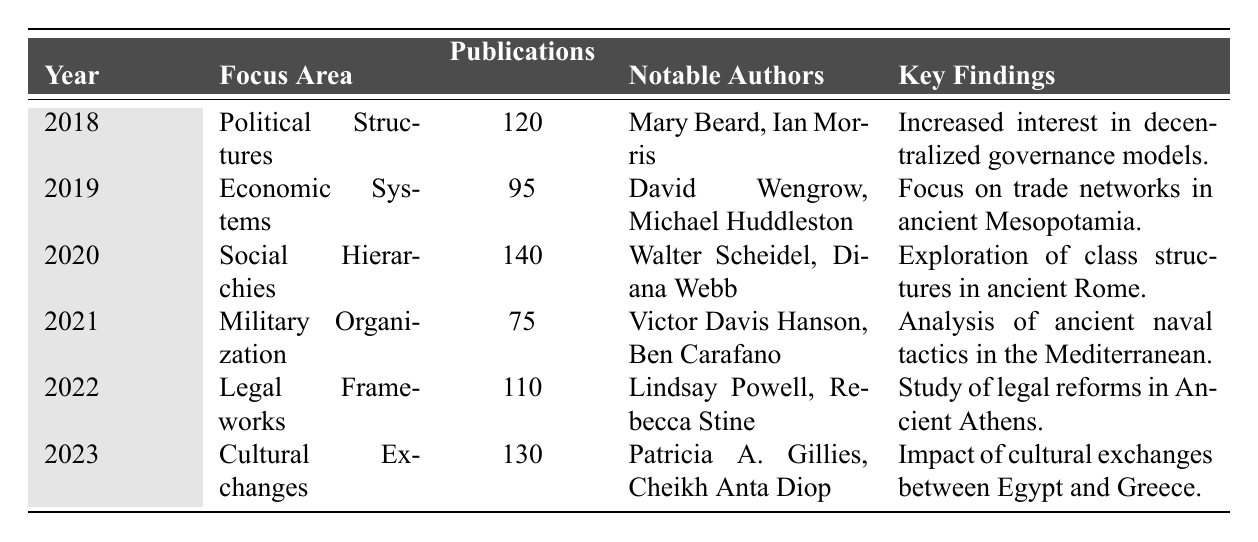What was the focus area of studies with the most publications in 2020? In 2020, the focus area with the most publications was "Social Hierarchies," which had 140 publications.
Answer: Social Hierarchies Who were the notable authors in the study of Legal Frameworks in 2022? The notable authors for the focus area of Legal Frameworks in 2022 were Lindsay Powell and Rebecca Stine.
Answer: Lindsay Powell, Rebecca Stine What was the number of publications in 2019 compared to 2021? In 2019, there were 95 publications, while in 2021, there were 75 publications. The difference is 95 - 75 = 20 publications.
Answer: 20 fewer publications Which years had more than 100 publications? The years with more than 100 publications are 2018 (120), 2020 (140), 2022 (110), and 2023 (130).
Answer: 2018, 2020, 2022, 2023 What is the average number of publications over the six years? The total number of publications is 120 + 95 + 140 + 75 + 110 + 130 = 770. There are 6 years, so the average is 770 / 6 ≈ 128.33.
Answer: Approximately 128.33 Which focus area had the least number of publications, and what were its key findings? The focus area with the least number of publications was "Military Organization" in 2021, with 75 publications. Its key findings were an analysis of ancient naval tactics in the Mediterranean.
Answer: Military Organization; Analysis of ancient naval tactics in the Mediterranean Was there an increase or decrease in publications from 2021 to 2022? In 2021, there were 75 publications and in 2022, there were 110 publications. This shows an increase of 110 - 75 = 35 publications.
Answer: Increase of 35 publications What focus area in 2023 focused on cultural exchanges and who were the notable authors? In 2023, the focus area was "Cultural Exchanges," and the notable authors were Patricia A. Gillies and Cheikh Anta Diop.
Answer: Cultural Exchanges; Patricia A. Gillies, Cheikh Anta Diop How many total publications were dedicated to Political Structures and Economic Systems combined? Political Structures had 120 publications and Economic Systems had 95. Therefore, the total is 120 + 95 = 215 publications.
Answer: 215 publications Which year saw an exploration of class structures in ancient Rome? The exploration of class structures in ancient Rome was conducted in 2020.
Answer: 2020 